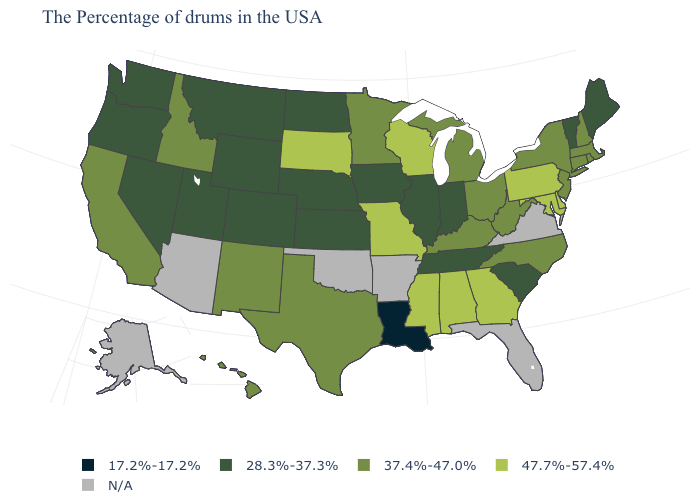What is the highest value in the USA?
Write a very short answer. 47.7%-57.4%. Name the states that have a value in the range 47.7%-57.4%?
Keep it brief. Delaware, Maryland, Pennsylvania, Georgia, Alabama, Wisconsin, Mississippi, Missouri, South Dakota. What is the lowest value in the USA?
Concise answer only. 17.2%-17.2%. Name the states that have a value in the range 28.3%-37.3%?
Keep it brief. Maine, Vermont, South Carolina, Indiana, Tennessee, Illinois, Iowa, Kansas, Nebraska, North Dakota, Wyoming, Colorado, Utah, Montana, Nevada, Washington, Oregon. Name the states that have a value in the range 37.4%-47.0%?
Be succinct. Massachusetts, Rhode Island, New Hampshire, Connecticut, New York, New Jersey, North Carolina, West Virginia, Ohio, Michigan, Kentucky, Minnesota, Texas, New Mexico, Idaho, California, Hawaii. What is the lowest value in the West?
Keep it brief. 28.3%-37.3%. Does the map have missing data?
Short answer required. Yes. What is the lowest value in the USA?
Concise answer only. 17.2%-17.2%. Name the states that have a value in the range 37.4%-47.0%?
Concise answer only. Massachusetts, Rhode Island, New Hampshire, Connecticut, New York, New Jersey, North Carolina, West Virginia, Ohio, Michigan, Kentucky, Minnesota, Texas, New Mexico, Idaho, California, Hawaii. Does Iowa have the lowest value in the MidWest?
Concise answer only. Yes. Name the states that have a value in the range N/A?
Short answer required. Virginia, Florida, Arkansas, Oklahoma, Arizona, Alaska. What is the value of Indiana?
Short answer required. 28.3%-37.3%. What is the lowest value in states that border Florida?
Answer briefly. 47.7%-57.4%. Does the map have missing data?
Write a very short answer. Yes. 